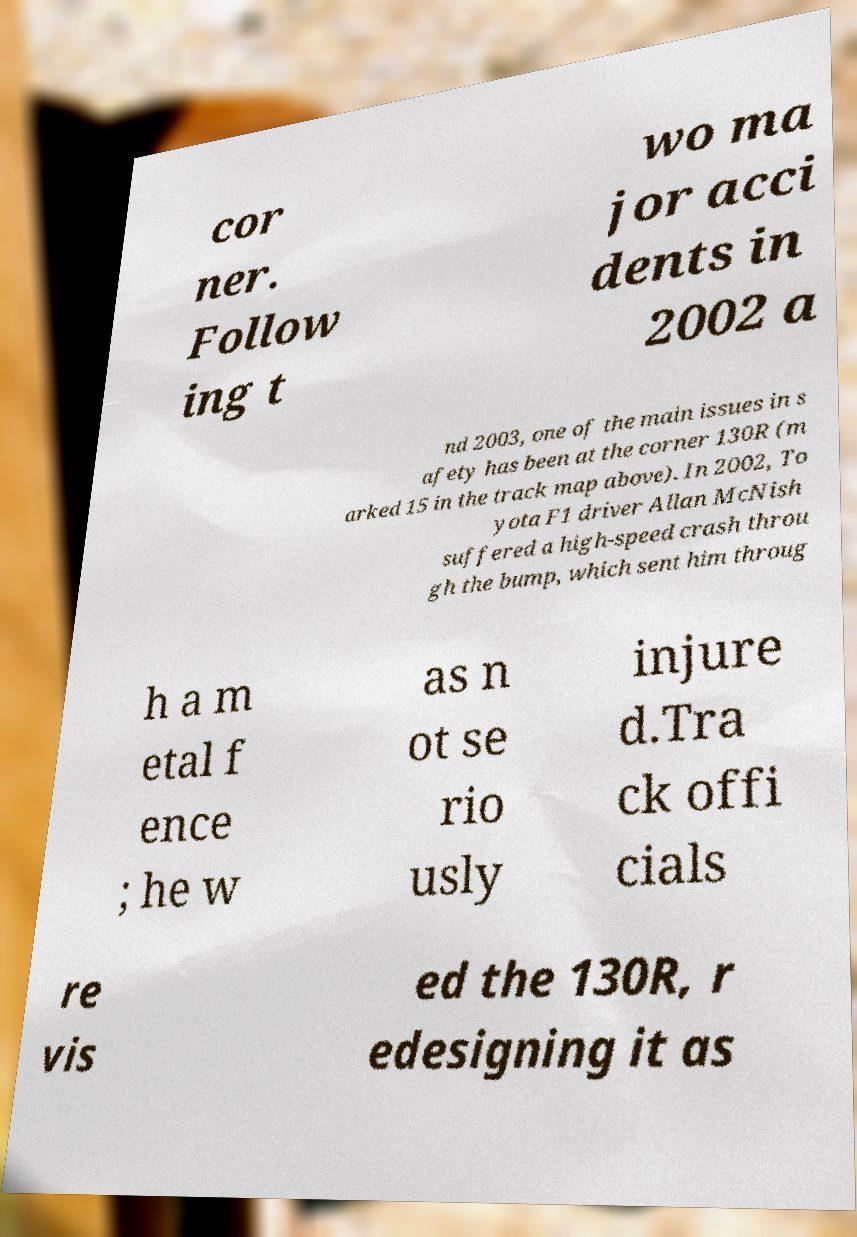Please read and relay the text visible in this image. What does it say? cor ner. Follow ing t wo ma jor acci dents in 2002 a nd 2003, one of the main issues in s afety has been at the corner 130R (m arked 15 in the track map above). In 2002, To yota F1 driver Allan McNish suffered a high-speed crash throu gh the bump, which sent him throug h a m etal f ence ; he w as n ot se rio usly injure d.Tra ck offi cials re vis ed the 130R, r edesigning it as 